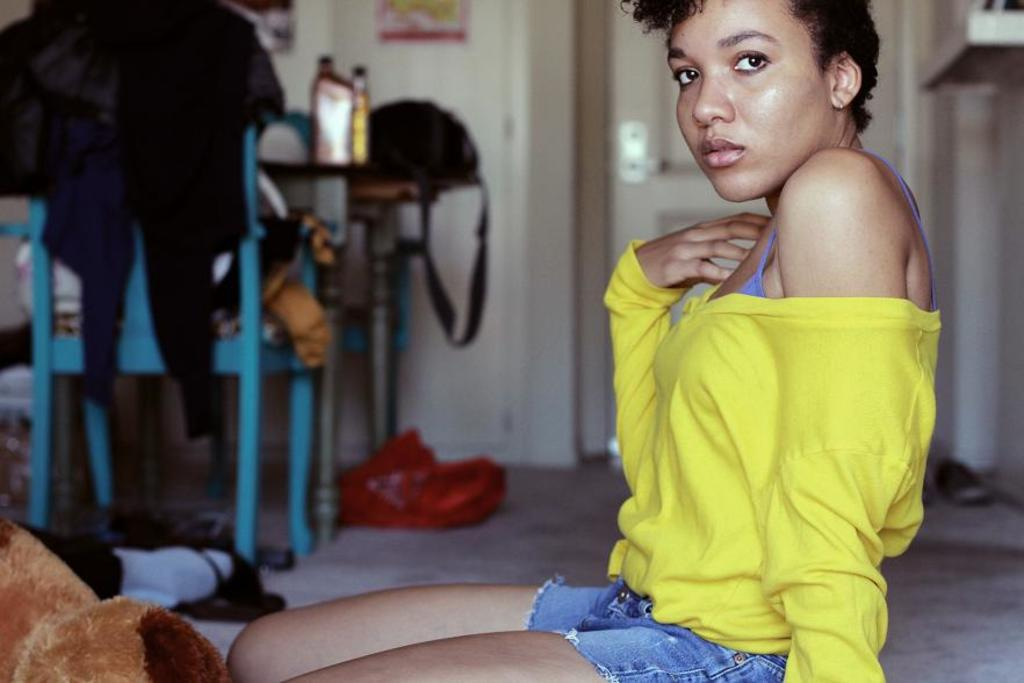Who is the main subject in the image? There is a woman in the image. What is the woman doing in the image? The woman is kneeling on the floor and posing for a photo. What else can be seen in the image besides the woman? There is a dining table in the image. How would you describe the state of the dining table? The dining table is messy. What type of stone is the woman holding in the image? There is no stone present in the image, and the woman is not holding anything. 